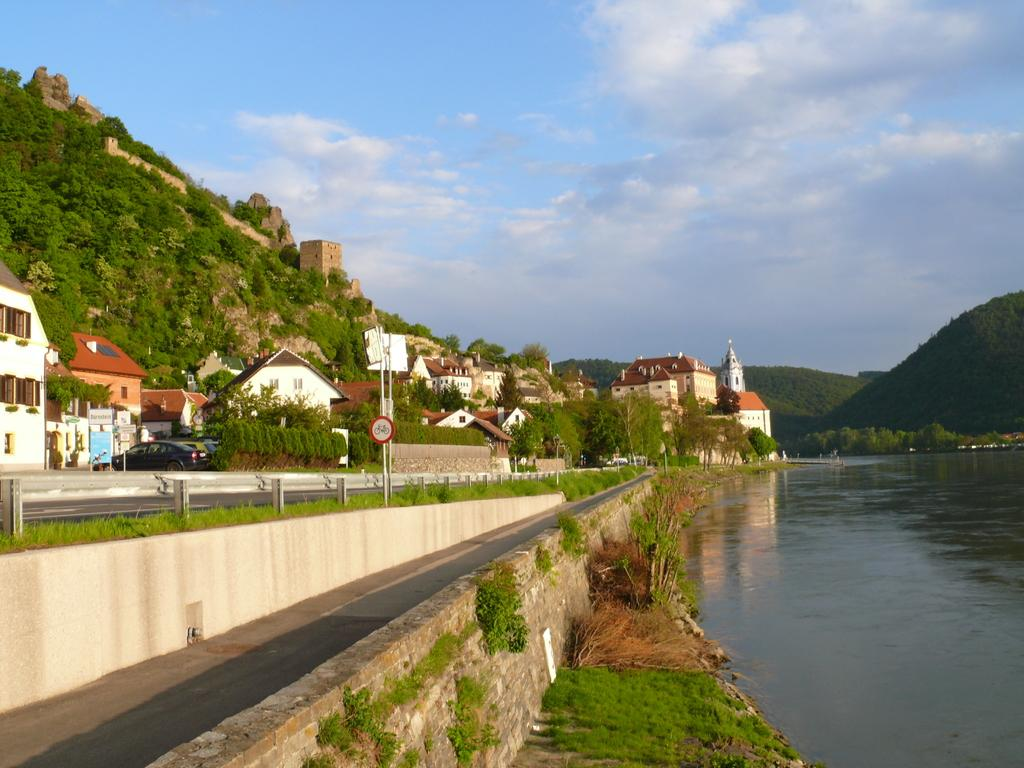What is one of the main elements in the image? There is water in the image. What else can be seen in the image besides water? There is a road, a signboard, poles, trees, vehicles, buildings with windows, and some objects in the image. Can you describe the landscape in the image? The image features mountains in the background, and the sky with clouds is visible. What type of structures are present in the image? There are buildings with windows in the image. How many vehicles can be seen in the image? There are vehicles in the image, but the exact number is not specified. What type of egg is being cooked on the signboard in the image? There is no egg present in the image, let alone being cooked on the signboard. How many robins can be seen perched on the poles in the image? There are no robins present in the image; the poles are not associated with any birds. 